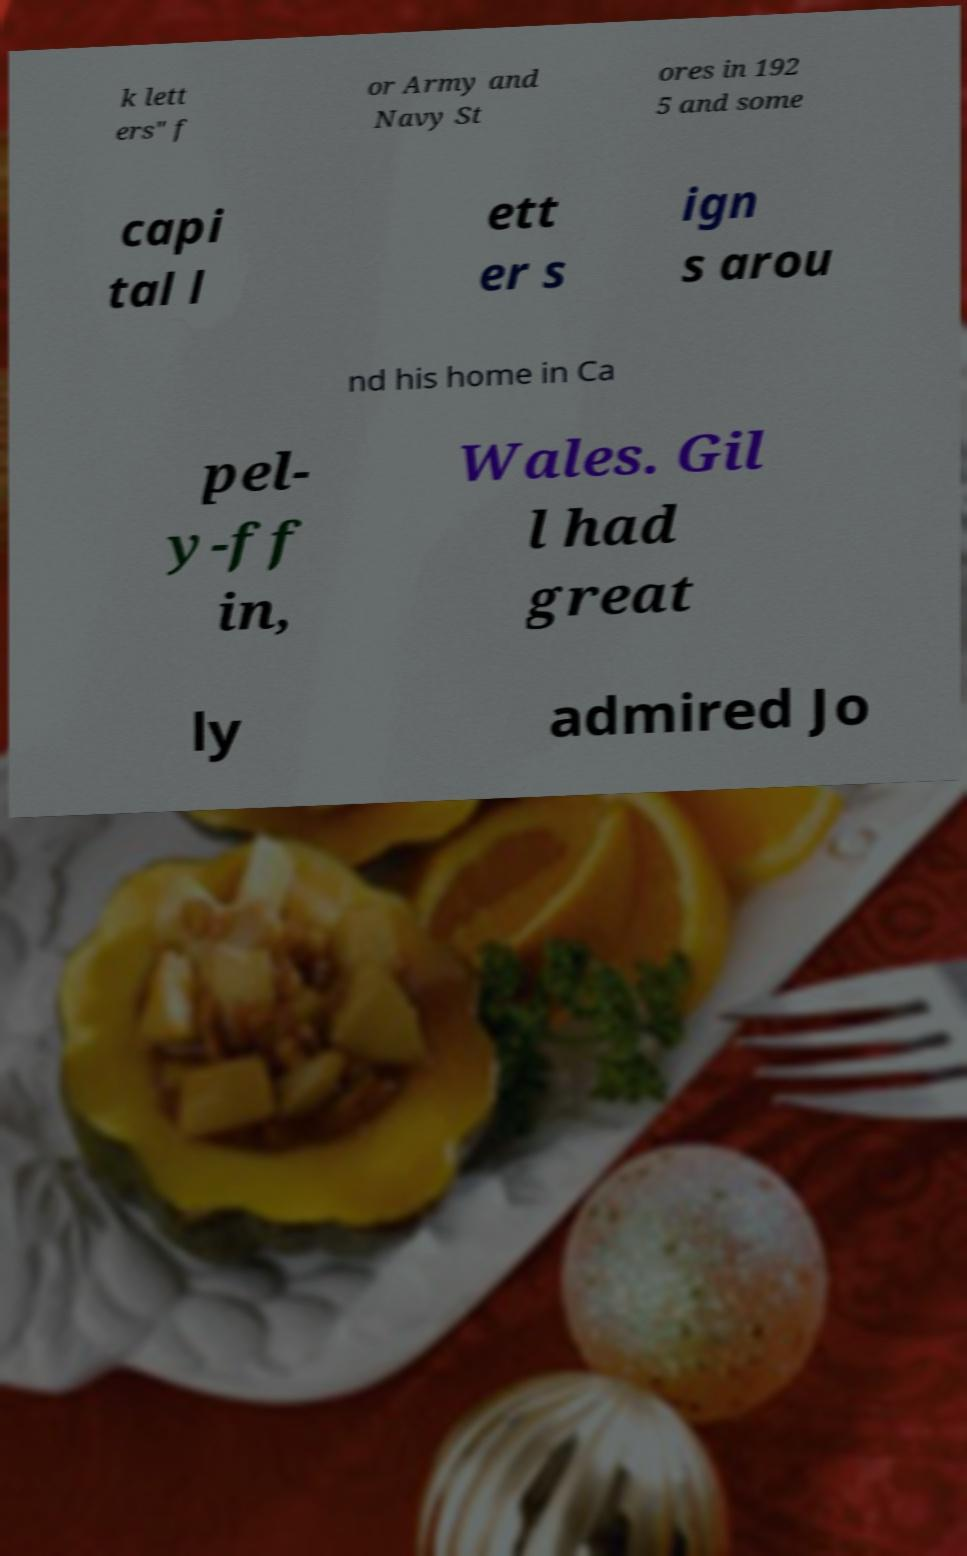Can you read and provide the text displayed in the image?This photo seems to have some interesting text. Can you extract and type it out for me? k lett ers" f or Army and Navy St ores in 192 5 and some capi tal l ett er s ign s arou nd his home in Ca pel- y-ff in, Wales. Gil l had great ly admired Jo 